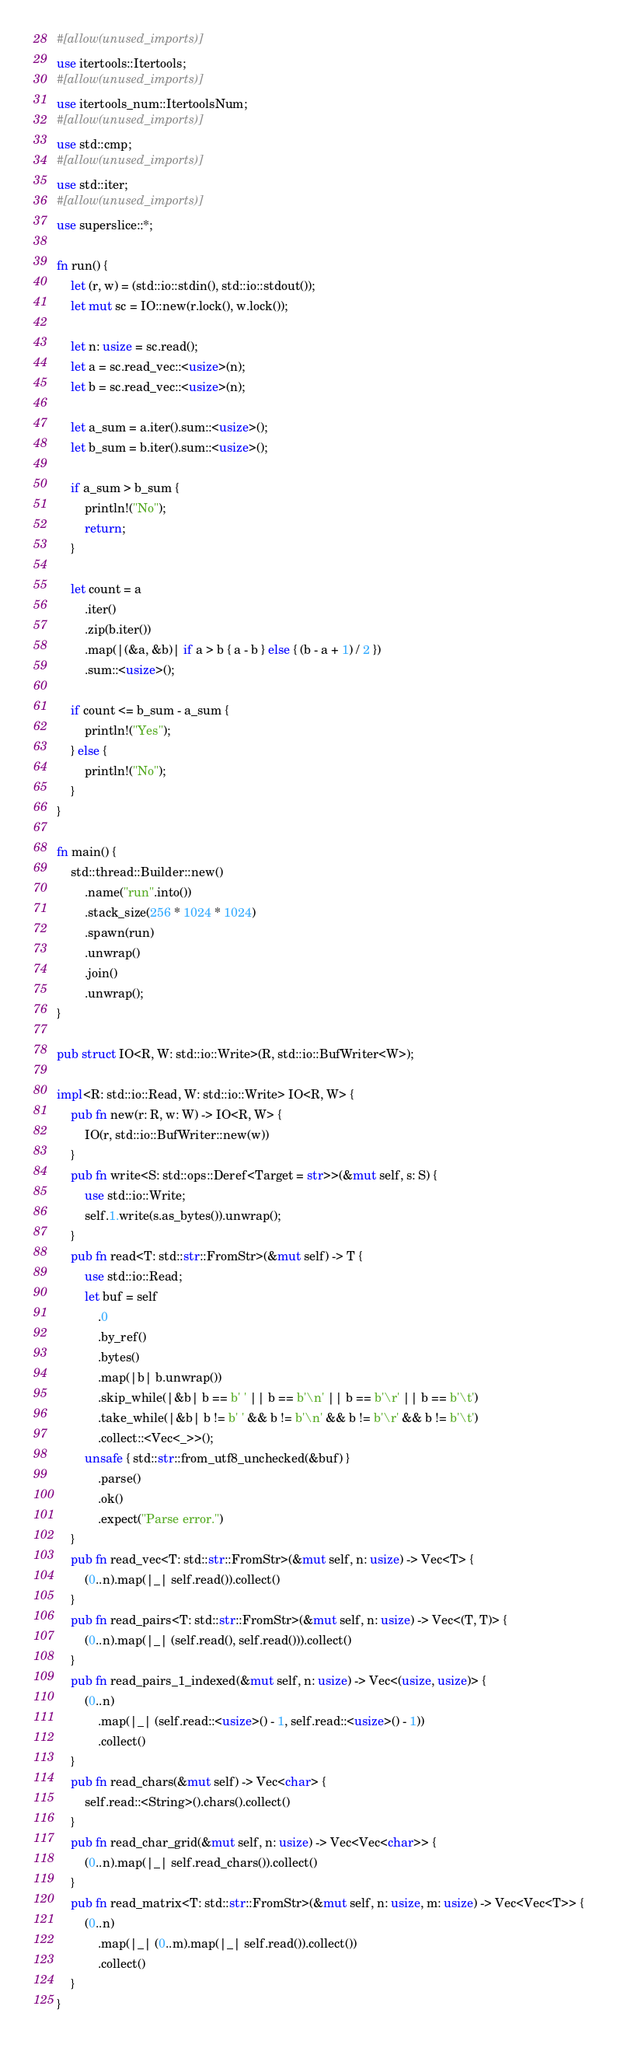Convert code to text. <code><loc_0><loc_0><loc_500><loc_500><_Rust_>#[allow(unused_imports)]
use itertools::Itertools;
#[allow(unused_imports)]
use itertools_num::ItertoolsNum;
#[allow(unused_imports)]
use std::cmp;
#[allow(unused_imports)]
use std::iter;
#[allow(unused_imports)]
use superslice::*;

fn run() {
    let (r, w) = (std::io::stdin(), std::io::stdout());
    let mut sc = IO::new(r.lock(), w.lock());

    let n: usize = sc.read();
    let a = sc.read_vec::<usize>(n);
    let b = sc.read_vec::<usize>(n);

    let a_sum = a.iter().sum::<usize>();
    let b_sum = b.iter().sum::<usize>();

    if a_sum > b_sum {
        println!("No");
        return;
    }

    let count = a
        .iter()
        .zip(b.iter())
        .map(|(&a, &b)| if a > b { a - b } else { (b - a + 1) / 2 })
        .sum::<usize>();

    if count <= b_sum - a_sum {
        println!("Yes");
    } else {
        println!("No");
    }
}

fn main() {
    std::thread::Builder::new()
        .name("run".into())
        .stack_size(256 * 1024 * 1024)
        .spawn(run)
        .unwrap()
        .join()
        .unwrap();
}

pub struct IO<R, W: std::io::Write>(R, std::io::BufWriter<W>);

impl<R: std::io::Read, W: std::io::Write> IO<R, W> {
    pub fn new(r: R, w: W) -> IO<R, W> {
        IO(r, std::io::BufWriter::new(w))
    }
    pub fn write<S: std::ops::Deref<Target = str>>(&mut self, s: S) {
        use std::io::Write;
        self.1.write(s.as_bytes()).unwrap();
    }
    pub fn read<T: std::str::FromStr>(&mut self) -> T {
        use std::io::Read;
        let buf = self
            .0
            .by_ref()
            .bytes()
            .map(|b| b.unwrap())
            .skip_while(|&b| b == b' ' || b == b'\n' || b == b'\r' || b == b'\t')
            .take_while(|&b| b != b' ' && b != b'\n' && b != b'\r' && b != b'\t')
            .collect::<Vec<_>>();
        unsafe { std::str::from_utf8_unchecked(&buf) }
            .parse()
            .ok()
            .expect("Parse error.")
    }
    pub fn read_vec<T: std::str::FromStr>(&mut self, n: usize) -> Vec<T> {
        (0..n).map(|_| self.read()).collect()
    }
    pub fn read_pairs<T: std::str::FromStr>(&mut self, n: usize) -> Vec<(T, T)> {
        (0..n).map(|_| (self.read(), self.read())).collect()
    }
    pub fn read_pairs_1_indexed(&mut self, n: usize) -> Vec<(usize, usize)> {
        (0..n)
            .map(|_| (self.read::<usize>() - 1, self.read::<usize>() - 1))
            .collect()
    }
    pub fn read_chars(&mut self) -> Vec<char> {
        self.read::<String>().chars().collect()
    }
    pub fn read_char_grid(&mut self, n: usize) -> Vec<Vec<char>> {
        (0..n).map(|_| self.read_chars()).collect()
    }
    pub fn read_matrix<T: std::str::FromStr>(&mut self, n: usize, m: usize) -> Vec<Vec<T>> {
        (0..n)
            .map(|_| (0..m).map(|_| self.read()).collect())
            .collect()
    }
}
</code> 